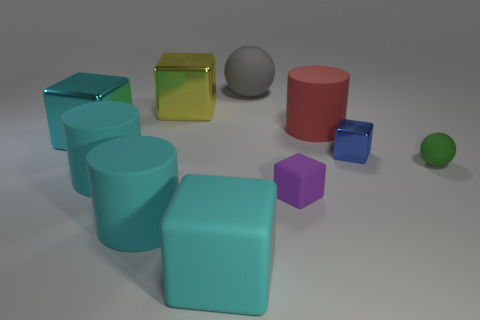There is a yellow shiny object that is the same shape as the tiny blue metal thing; what size is it?
Provide a succinct answer. Large. Is the material of the tiny object that is in front of the small green thing the same as the blue cube?
Ensure brevity in your answer.  No. Does the cyan metal object have the same shape as the green thing?
Provide a succinct answer. No. What number of things are big cylinders that are right of the large rubber sphere or large things?
Your answer should be compact. 7. There is a block that is made of the same material as the tiny purple object; what is its size?
Your answer should be compact. Large. What number of other cubes have the same color as the big rubber block?
Offer a very short reply. 1. What number of big objects are cubes or green things?
Make the answer very short. 3. Is there a tiny sphere that has the same material as the big gray thing?
Your answer should be very brief. Yes. There is a cyan block that is behind the green sphere; what material is it?
Give a very brief answer. Metal. Is the color of the block left of the big yellow metallic cube the same as the large block in front of the green matte sphere?
Ensure brevity in your answer.  Yes. 